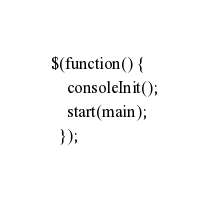Convert code to text. <code><loc_0><loc_0><loc_500><loc_500><_JavaScript_>
$(function() {
    consoleInit();
    start(main);
  });
</code> 